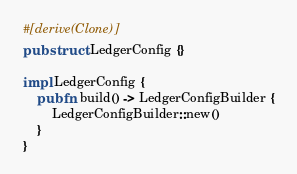<code> <loc_0><loc_0><loc_500><loc_500><_Rust_>#[derive(Clone)]
pub struct LedgerConfig {}

impl LedgerConfig {
    pub fn build() -> LedgerConfigBuilder {
        LedgerConfigBuilder::new()
    }
}
</code> 